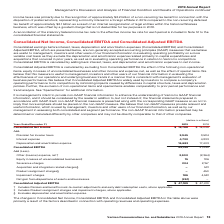According to Verizon Communications's financial document, How is Consolidated Adjusted EBITDA calculated? by excluding from Consolidated EBITDA the effect of the following non-operational items: equity in losses of unconsolidated businesses and other income and expense, net, as well as the effect of special items.. The document states: "Consolidated Adjusted EBITDA is calculated by excluding from Consolidated EBITDA the effect of the following non-operational items: equity in losses o..." Also, Why is Consolidated Adjusted EBITDA useful? evaluating the effectiveness of our operations and underlying business trends in a manner that is consistent with management’s evaluation of business performance.. The document states: "rs and other users of our financial information in evaluating the effectiveness of our operations and underlying business trends in a manner that is c..." Also, What is the Consolidated Net Income in 2019? According to the financial document, $19,788 (in millions). The relevant text states: "Consolidated Net Income $ 19,788 $ 16,039..." Also, can you calculate: What is the change in Consolidated Net Income from 2018 to 2019? Based on the calculation: 19,788-16,039, the result is 3749 (in millions). This is based on the information: "Consolidated Net Income $ 19,788 $ 16,039 Consolidated Net Income $ 19,788 $ 16,039..." The key data points involved are: 16,039, 19,788. Also, can you calculate: What is the change in Consolidated EBITDA from 2018 to 2019? Based on the calculation: 44,145-41,859, the result is 2286 (in millions). This is based on the information: "Consolidated EBITDA 44,145 41,859 Consolidated EBITDA 44,145 41,859..." The key data points involved are: 41,859, 44,145. Also, can you calculate: What is the change in Consolidated Adjusted EBITDA from 2018 to 2019? Based on the calculation: 47,189-47,410, the result is -221 (in millions). This is based on the information: "Consolidated Adjusted EBITDA $ 47,189 $ 47,410 Consolidated Adjusted EBITDA $ 47,189 $ 47,410..." The key data points involved are: 47,189, 47,410. 